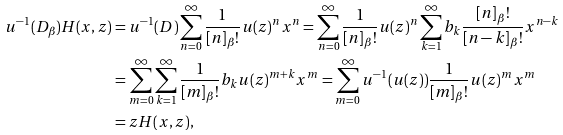Convert formula to latex. <formula><loc_0><loc_0><loc_500><loc_500>u ^ { - 1 } ( D _ { \beta } ) H ( x , z ) & = u ^ { - 1 } ( D ) \sum _ { n = 0 } ^ { \infty } \frac { 1 } { [ n ] _ { \beta } ! } u ( z ) ^ { n } x ^ { n } = \sum _ { n = 0 } ^ { \infty } \frac { 1 } { [ n ] _ { \beta } ! } u ( z ) ^ { n } \sum _ { k = 1 } ^ { \infty } b _ { k } \frac { [ n ] _ { \beta } ! } { [ n - k ] _ { \beta } ! } x ^ { n - k } \\ & = \sum _ { m = 0 } ^ { \infty } \sum _ { k = 1 } ^ { \infty } \frac { 1 } { [ m ] _ { \beta } ! } b _ { k } u ( z ) ^ { m + k } x ^ { m } = \sum _ { m = 0 } ^ { \infty } u ^ { - 1 } ( u ( z ) ) \frac { 1 } { [ m ] _ { \beta } ! } u ( z ) ^ { m } x ^ { m } \\ & = z H ( x , z ) ,</formula> 